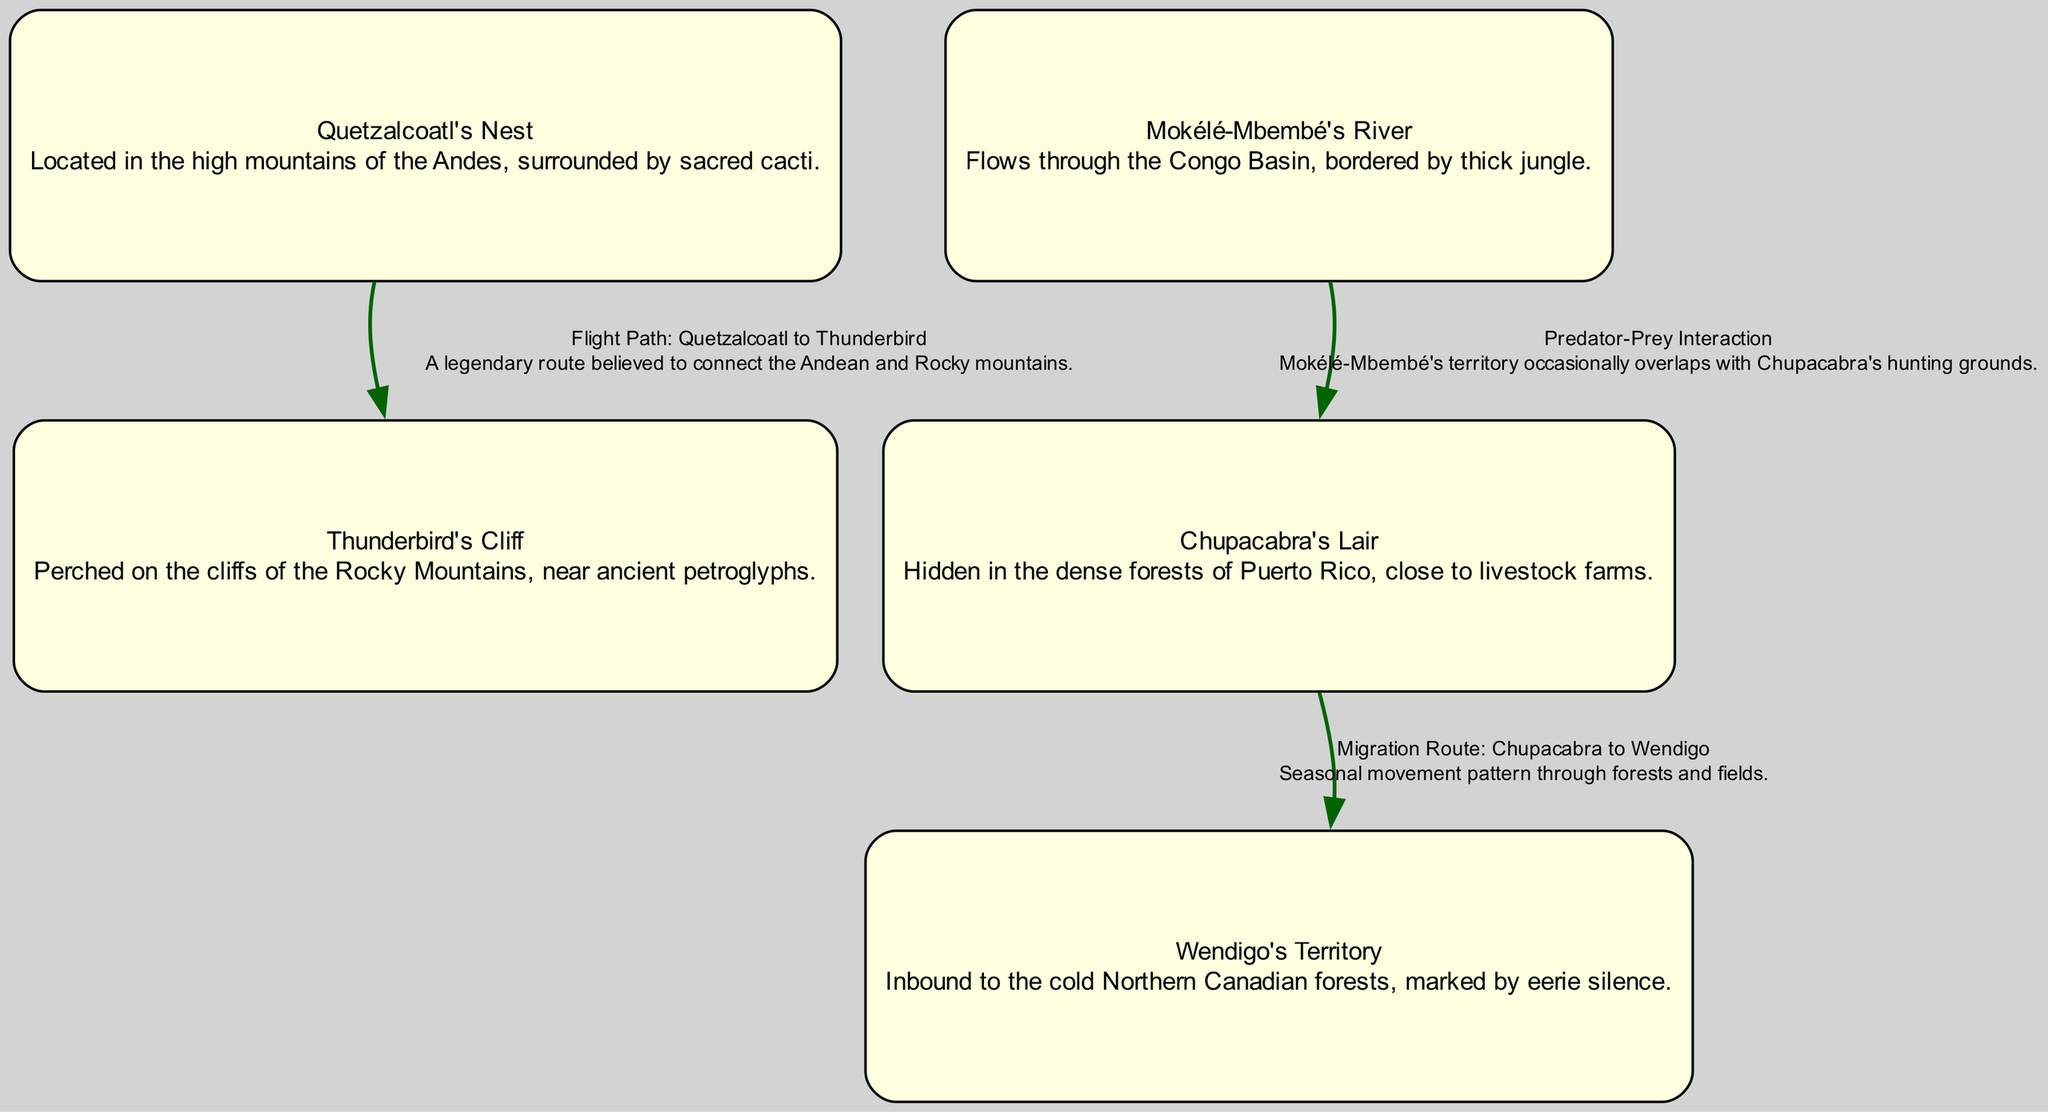What is the total number of nodes in the diagram? The diagram lists five unique locations where legendary creatures are said to inhabit, which corresponds to the total count of nodes represented.
Answer: 5 Which creature is associated with "Thunderbird's Cliff"? The label indicates that the Thunderbird is the creature connected to this specific location, clearly noted in the diagram.
Answer: Thunderbird What is the relationship between "Chupacabra's Lair" and "Wendigo's Territory"? The diagram shows a migration route connecting these two locations, indicating a seasonal movement between them.
Answer: Migration Route Where is "Mokélé-Mbembé's River" located? The diagram specifies that Mokélé-Mbembé’s habitat is situated in the Congo Basin, amidst thick jungles.
Answer: Congo Basin What type of interaction is depicted between "Mokélé-Mbembé" and "Chupacabra"? The diagram explicitly describes this as a predator-prey interaction, highlighting the relationship between the two creatures.
Answer: Predator-Prey Interaction Which two locations are connected by the flight path labeled "Flight Path: Quetzalcoatl to Thunderbird"? The edges in the diagram clearly indicate a connection between Quetzalcoatl's Nest and Thunderbird's Cliff.
Answer: Quetzalcoatl's Nest and Thunderbird's Cliff How many edges are illustrated in the diagram? By counting the edges drawn in the diagram, it can be determined that there are three connections depicted between the nodes.
Answer: 3 What natural feature surrounds "Quetzalcoatl's Nest"? The description associated with Quetzalcoatl's Nest in the diagram notes that it is surrounded by sacred cacti.
Answer: Sacred cacti In which geographical area is "Wendigo's Territory" located? The diagram describes Wendigo's Territory as being inbound to cold Northern Canadian forests, which specifies its location.
Answer: Northern Canadian forests 